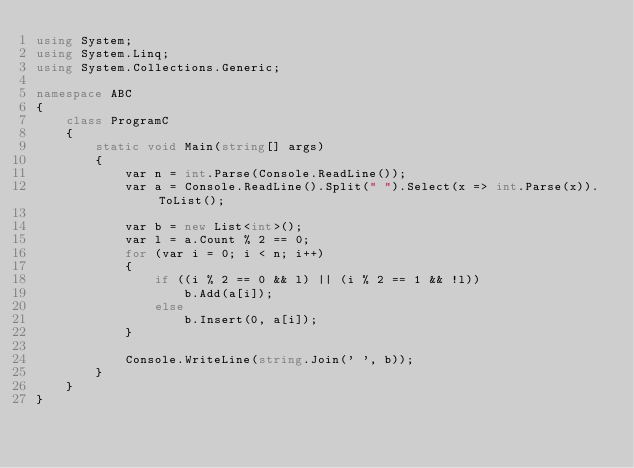<code> <loc_0><loc_0><loc_500><loc_500><_C#_>using System;
using System.Linq;
using System.Collections.Generic;

namespace ABC
{
    class ProgramC
    {
        static void Main(string[] args)
        {
            var n = int.Parse(Console.ReadLine());
            var a = Console.ReadLine().Split(" ").Select(x => int.Parse(x)).ToList();

            var b = new List<int>();
            var l = a.Count % 2 == 0;
            for (var i = 0; i < n; i++)
            {
                if ((i % 2 == 0 && l) || (i % 2 == 1 && !l))
                    b.Add(a[i]);
                else
                    b.Insert(0, a[i]);
            }

            Console.WriteLine(string.Join(' ', b));
        }
    }
}
</code> 